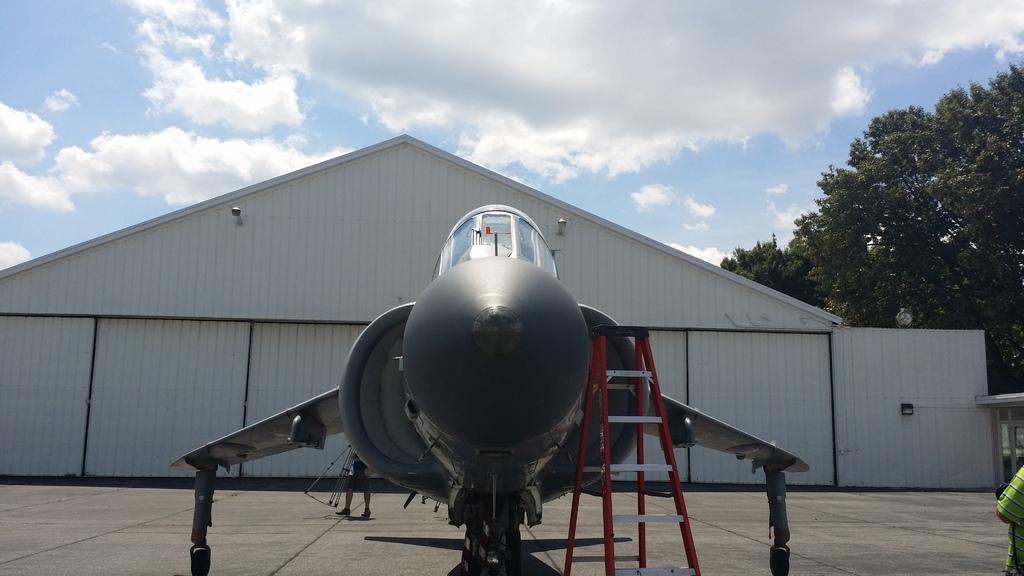Can you describe this image briefly? In the center of the image, we can see an aeroplane and in the background, there is a shed and we can see some trees and there is a person, on the bottom right. At the top, there are clouds in the sky. 